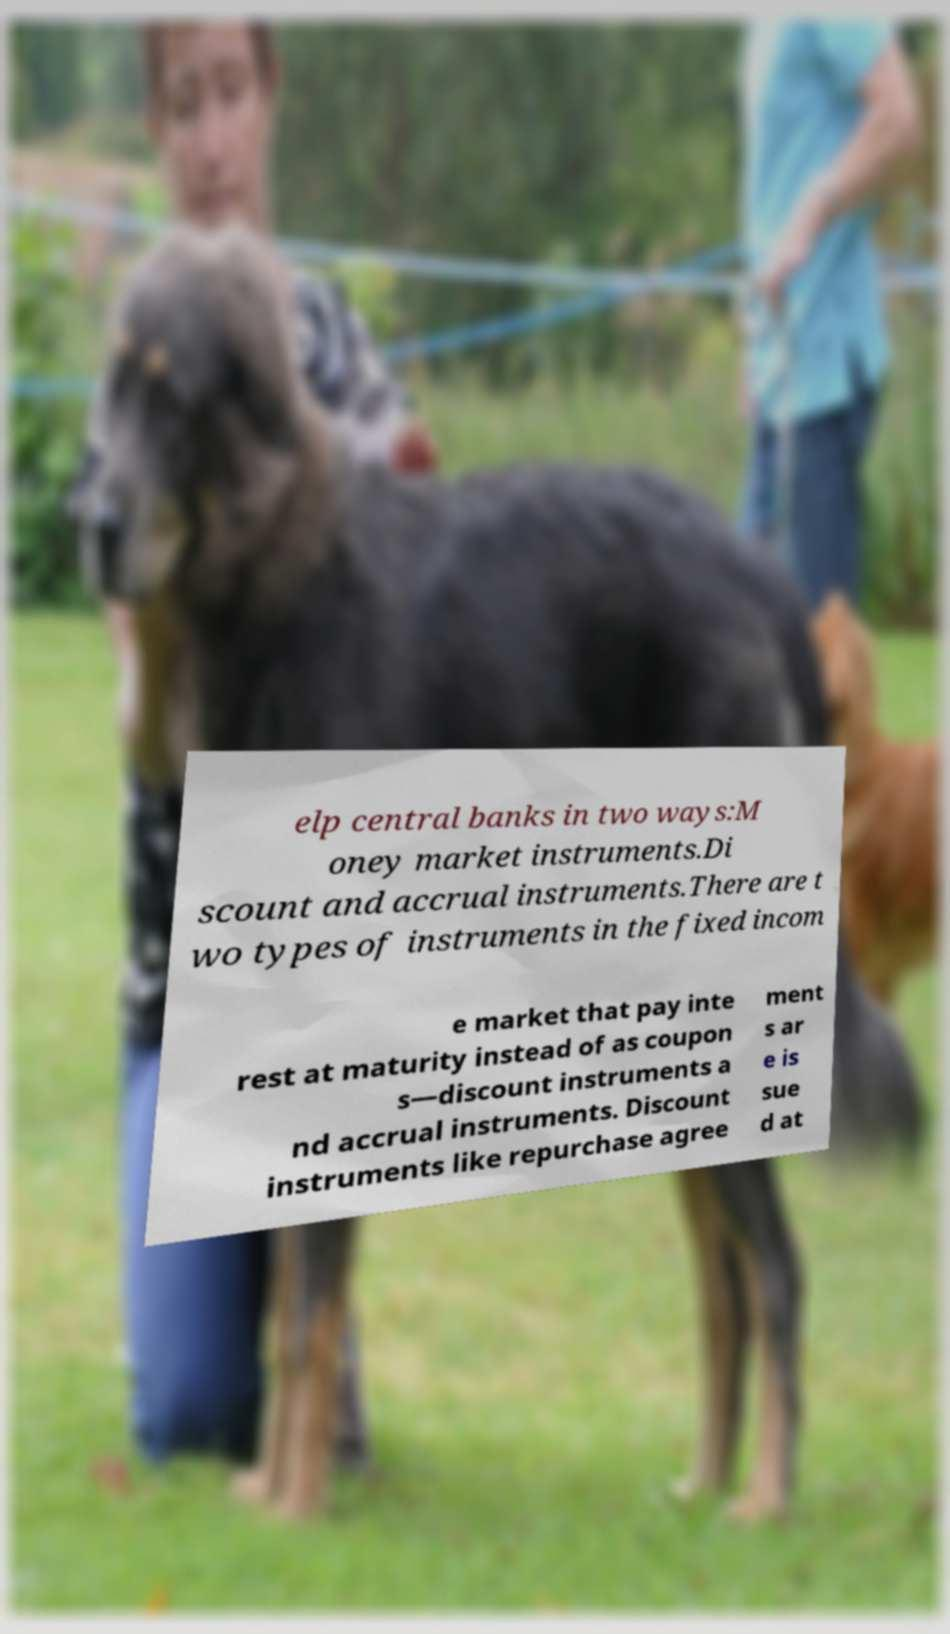Please identify and transcribe the text found in this image. elp central banks in two ways:M oney market instruments.Di scount and accrual instruments.There are t wo types of instruments in the fixed incom e market that pay inte rest at maturity instead of as coupon s—discount instruments a nd accrual instruments. Discount instruments like repurchase agree ment s ar e is sue d at 